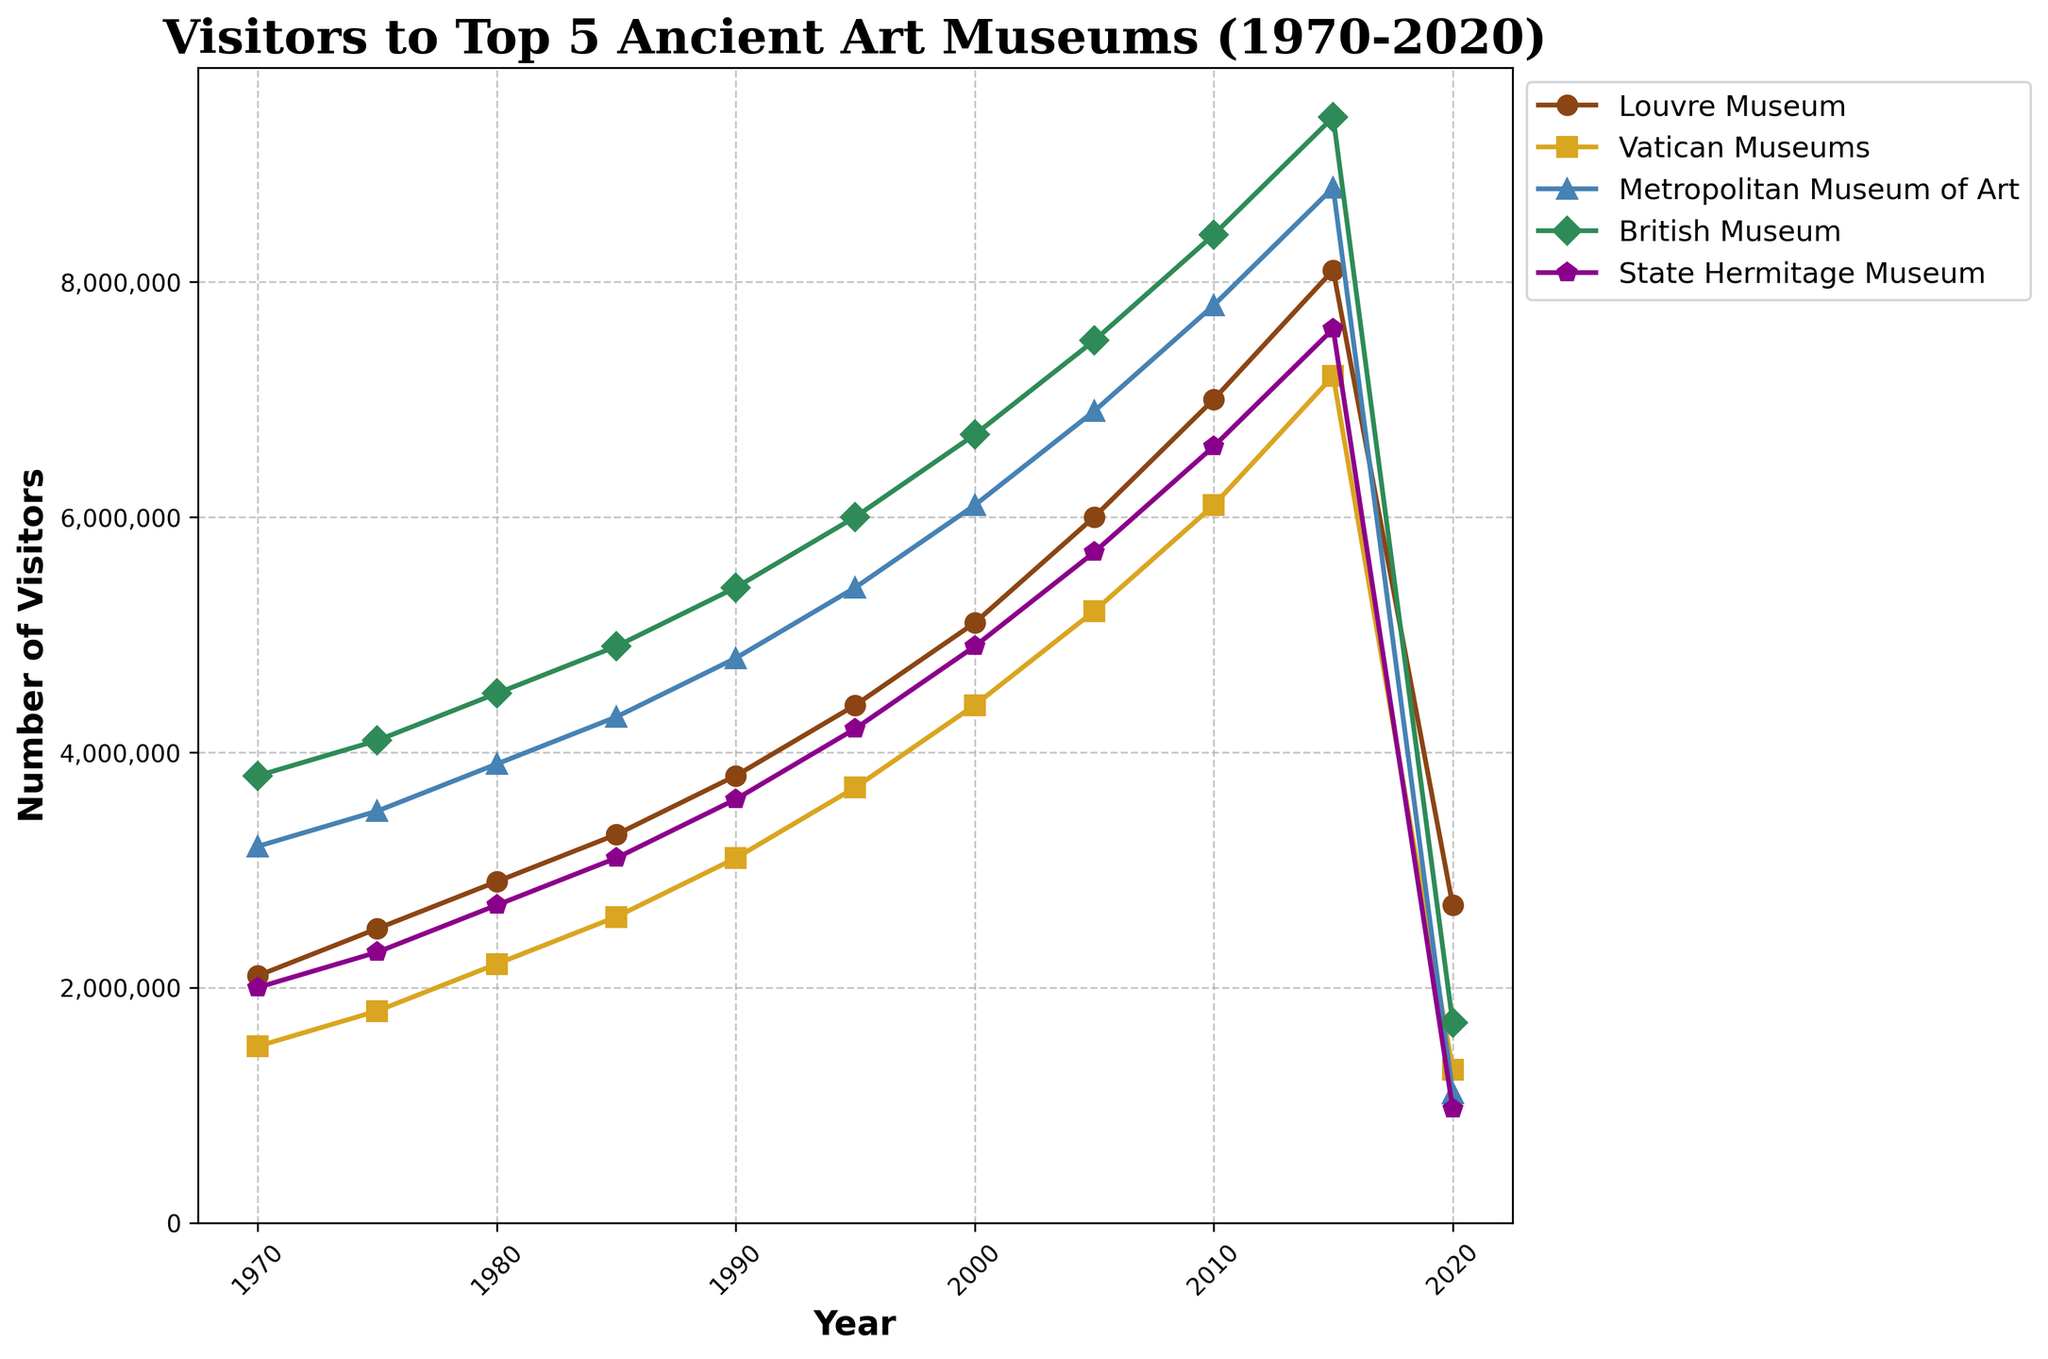How many visitors did the Louvre Museum have in 2010? Look for the data point for the Louvre Museum in 2010 directly on the plot.
Answer: 7,000,000 Which museum had the highest number of visitors in 2020? Identify the data point that is the highest among all museums for the year 2020.
Answer: British Museum By how much did the number of visitors to the Metropolitan Museum of Art increase from 1970 to 2010? Subtract the number of visitors in 1970 from the number of visitors in 2010 for the Metropolitan Museum of Art. 7,800,000 - 3,200,000 = 4,600,000
Answer: 4,600,000 What was the average number of visitors to the State Hermitage Museum between 2000 and 2010? Average the data points for the State Hermitage Museum for the years 2000, 2005, and 2010. (4,900,000 + 5,700,000 + 6,600,000) / 3 = 5,733,333.34
Answer: 5733333.34 Which two museums had the closest number of visitors in 2015? Compare the data points for all museums in 2015 and identify the two that have the smallest difference.
Answer: Vatican Museums and State Hermitage Museum What is the trend of visitors to the British Museum from 1970 to 2020? Identify whether there is an overall increase, decrease, or irregular pattern for the British Museum from 1970 to 2020.
Answer: Increasing, sharp drop in 2020 Between which consecutive years did the Louvre Museum see the highest increase in visitor numbers? Calculate the difference in visitors between each pair of consecutive years and identify the highest difference.
Answer: 2000 to 2005 How many visitors did the State Hermitage Museum have in 2010 minus the visitors to the Vatican Museums in 2020? Subtract the number of visitors to the Vatican Museums in 2020 from the number of visitors to the State Hermitage Museum in 2010. 6,600,000 - 1,300,000 = 5,300,000
Answer: 5,300,000 What is the total number of visitors for all museums combined in 1985? Add the visitors of all museums together for the year 1985. 3,300,000 + 2,600,000 + 4,300,000 + 4,900,000 + 3,100,000 = 18,200,000
Answer: 18,200,000 